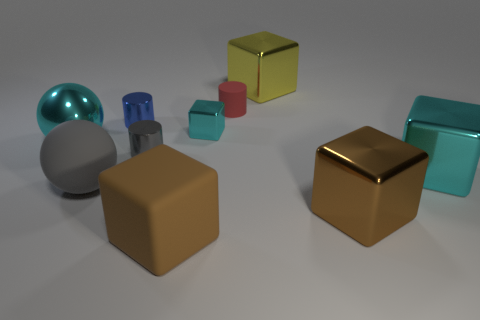Subtract all small blocks. How many blocks are left? 4 Subtract all red cylinders. How many brown cubes are left? 2 Subtract all cyan cubes. How many cubes are left? 3 Subtract 3 cylinders. How many cylinders are left? 0 Subtract all balls. How many objects are left? 8 Add 3 large red matte cylinders. How many large red matte cylinders exist? 3 Subtract 0 green cylinders. How many objects are left? 10 Subtract all red spheres. Subtract all gray cubes. How many spheres are left? 2 Subtract all small shiny objects. Subtract all tiny yellow matte balls. How many objects are left? 7 Add 5 large brown blocks. How many large brown blocks are left? 7 